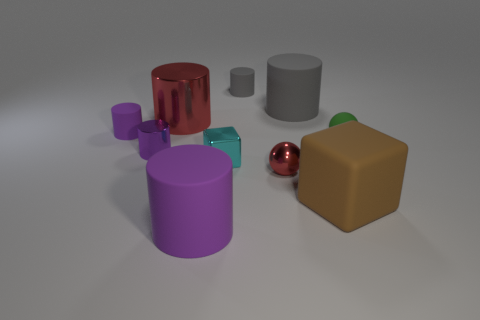What number of other things are there of the same size as the cyan cube?
Offer a terse response. 5. There is a shiny cylinder that is the same color as the small shiny sphere; what is its size?
Make the answer very short. Large. The green object has what shape?
Provide a succinct answer. Sphere. There is a big object that is behind the tiny rubber ball and on the right side of the small block; what is its color?
Your answer should be very brief. Gray. What is the small green thing made of?
Your answer should be compact. Rubber. What shape is the purple rubber thing that is in front of the small green object?
Offer a terse response. Cylinder. What is the color of the metallic block that is the same size as the green ball?
Provide a succinct answer. Cyan. Is the material of the purple thing that is behind the green rubber thing the same as the large purple thing?
Offer a terse response. Yes. There is a matte thing that is behind the big purple cylinder and in front of the cyan metal cube; what is its size?
Provide a succinct answer. Large. There is a purple matte object that is in front of the cyan thing; how big is it?
Offer a terse response. Large. 